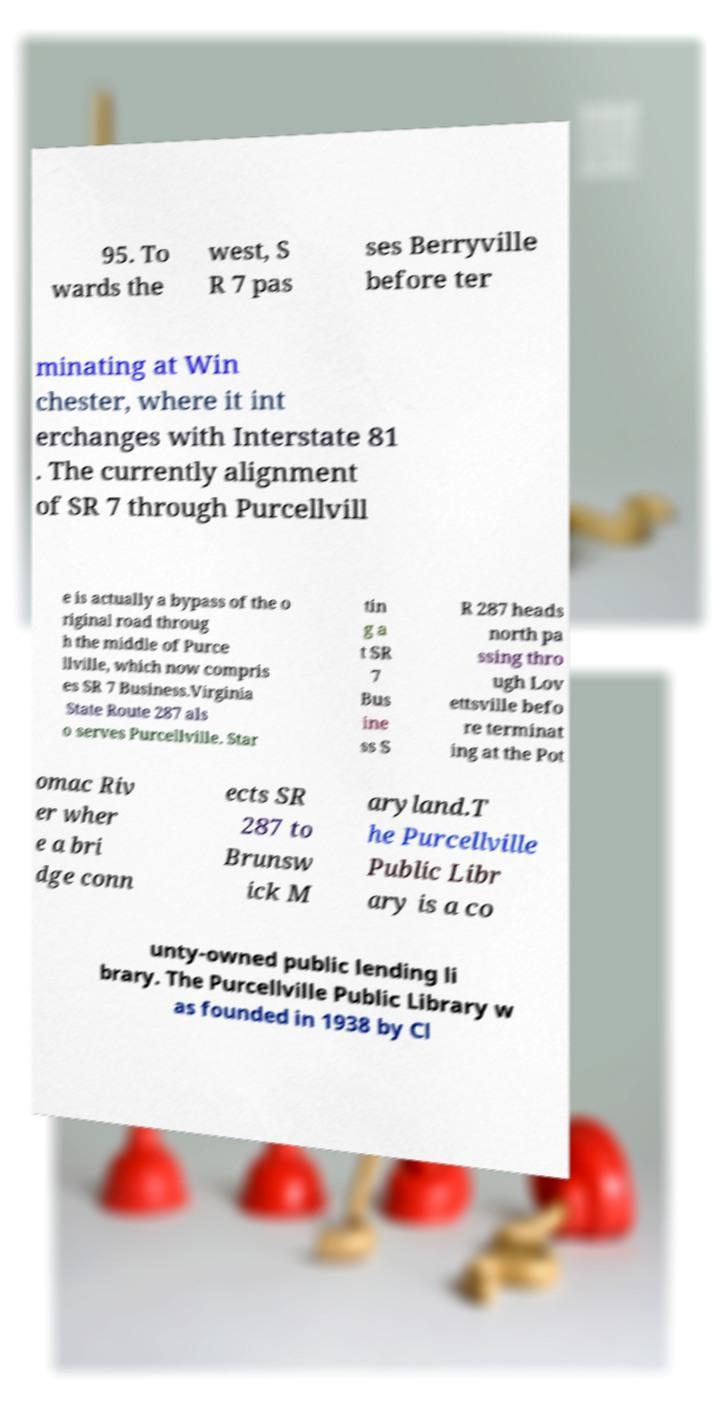What messages or text are displayed in this image? I need them in a readable, typed format. 95. To wards the west, S R 7 pas ses Berryville before ter minating at Win chester, where it int erchanges with Interstate 81 . The currently alignment of SR 7 through Purcellvill e is actually a bypass of the o riginal road throug h the middle of Purce llville, which now compris es SR 7 Business.Virginia State Route 287 als o serves Purcellville. Star tin g a t SR 7 Bus ine ss S R 287 heads north pa ssing thro ugh Lov ettsville befo re terminat ing at the Pot omac Riv er wher e a bri dge conn ects SR 287 to Brunsw ick M aryland.T he Purcellville Public Libr ary is a co unty-owned public lending li brary. The Purcellville Public Library w as founded in 1938 by Cl 